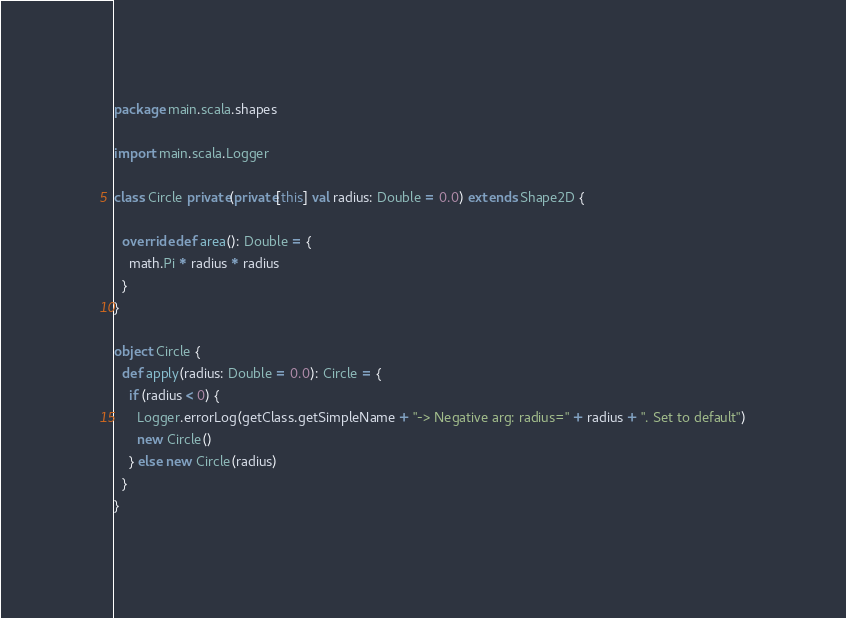Convert code to text. <code><loc_0><loc_0><loc_500><loc_500><_Scala_>package main.scala.shapes

import main.scala.Logger

class Circle private(private[this] val radius: Double = 0.0) extends Shape2D {

  override def area(): Double = {
    math.Pi * radius * radius
  }
}

object Circle {
  def apply(radius: Double = 0.0): Circle = {
    if (radius < 0) {
      Logger.errorLog(getClass.getSimpleName + "-> Negative arg: radius=" + radius + ". Set to default")
      new Circle()
    } else new Circle(radius)
  }
}</code> 